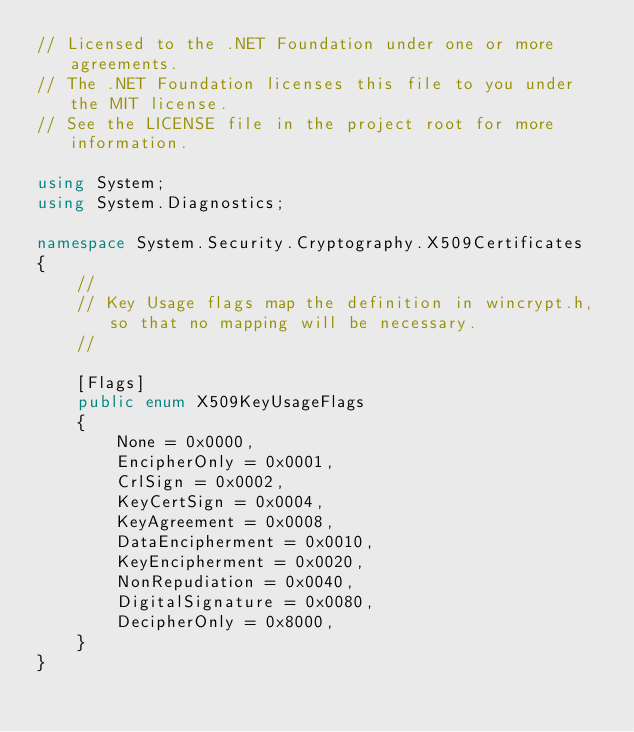Convert code to text. <code><loc_0><loc_0><loc_500><loc_500><_C#_>// Licensed to the .NET Foundation under one or more agreements.
// The .NET Foundation licenses this file to you under the MIT license.
// See the LICENSE file in the project root for more information.

using System;
using System.Diagnostics;

namespace System.Security.Cryptography.X509Certificates
{
    //
    // Key Usage flags map the definition in wincrypt.h, so that no mapping will be necessary.
    //

    [Flags]
    public enum X509KeyUsageFlags
    {
        None = 0x0000,
        EncipherOnly = 0x0001,
        CrlSign = 0x0002,
        KeyCertSign = 0x0004,
        KeyAgreement = 0x0008,
        DataEncipherment = 0x0010,
        KeyEncipherment = 0x0020,
        NonRepudiation = 0x0040,
        DigitalSignature = 0x0080,
        DecipherOnly = 0x8000,
    }
}

</code> 